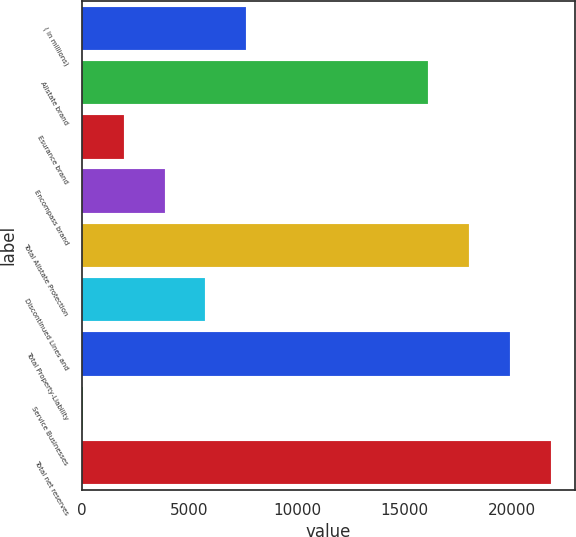Convert chart to OTSL. <chart><loc_0><loc_0><loc_500><loc_500><bar_chart><fcel>( in millions)<fcel>Allstate brand<fcel>Esurance brand<fcel>Encompass brand<fcel>Total Allstate Protection<fcel>Discontinued Lines and<fcel>Total Property-Liability<fcel>Service Businesses<fcel>Total net reserves<nl><fcel>7640.8<fcel>16108<fcel>1928.2<fcel>3832.4<fcel>18012.2<fcel>5736.6<fcel>19916.4<fcel>24<fcel>21820.6<nl></chart> 